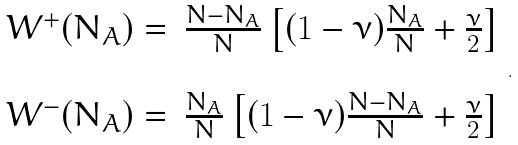Convert formula to latex. <formula><loc_0><loc_0><loc_500><loc_500>\begin{array} { l l } W ^ { + } ( N _ { A } ) = & \frac { N - N _ { A } } { N } \left [ ( 1 - \nu ) \frac { N _ { A } } { N } + \frac { \nu } { 2 } \right ] \\ \\ W ^ { - } ( N _ { A } ) = & \frac { N _ { A } } { N } \left [ ( 1 - \nu ) \frac { N - N _ { A } } { N } + \frac { \nu } { 2 } \right ] \end{array} .</formula> 